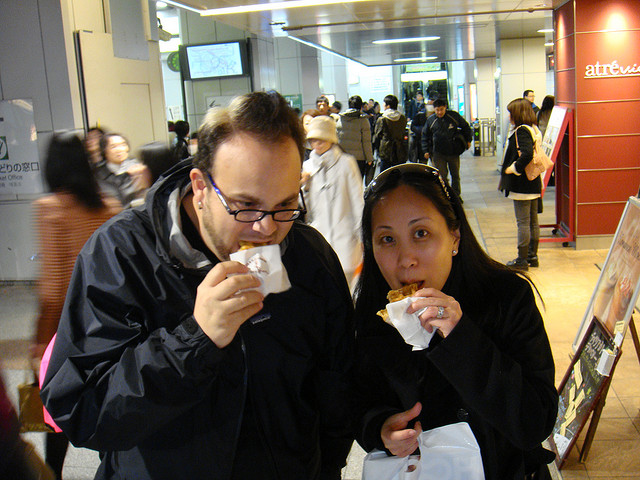Please identify all text content in this image. atre 